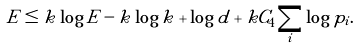<formula> <loc_0><loc_0><loc_500><loc_500>E \leq k \log E - k \log k + \log d + k C _ { 4 } \sum _ { i } \log p _ { i } .</formula> 